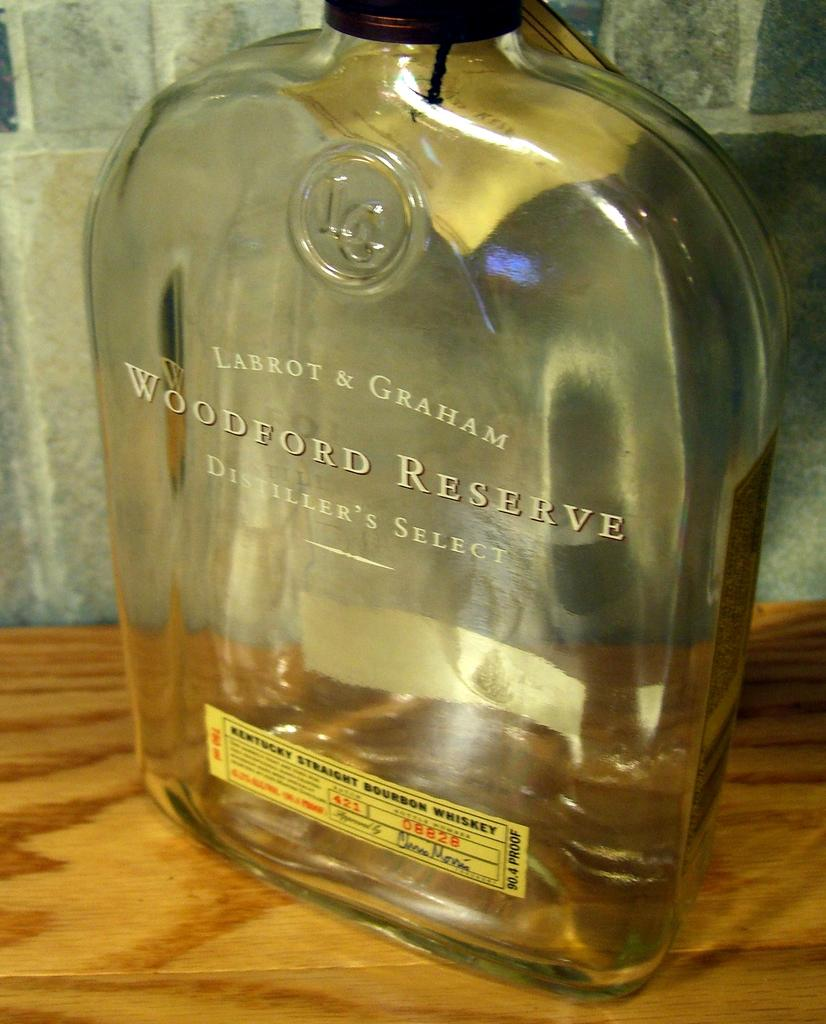<image>
Provide a brief description of the given image. A large clear bottle of Woodford Reserve alcohol. 